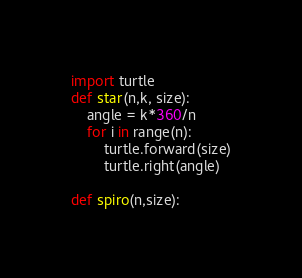Convert code to text. <code><loc_0><loc_0><loc_500><loc_500><_Python_>import turtle
def star(n,k, size):
	angle = k*360/n
	for i in range(n):
		turtle.forward(size)
		turtle.right(angle)

def spiro(n,size):

</code> 